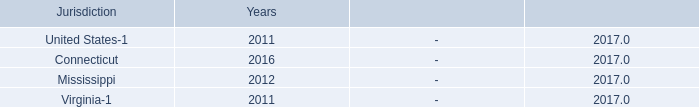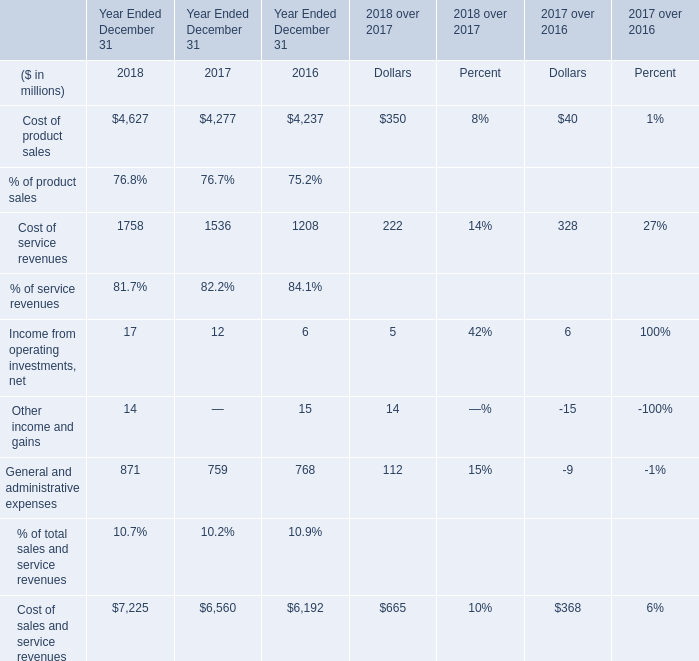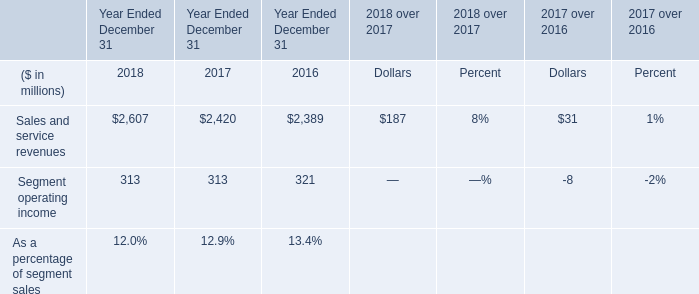What is the sum of Income from operating investments, net ,Other income and gains and General and administrative expenses in 2016? (in million) 
Computations: ((6 + 15) + 768)
Answer: 789.0. What's the total amount of the Cost of service revenues in the years where operating investments, net greater than 0? (in million) 
Computations: ((1758 + 1536) + 1208)
Answer: 4502.0. what is the liability for interest and penalties as of december 31 , 2016? 
Computations: ((1 + 2) - 2)
Answer: 1.0. 